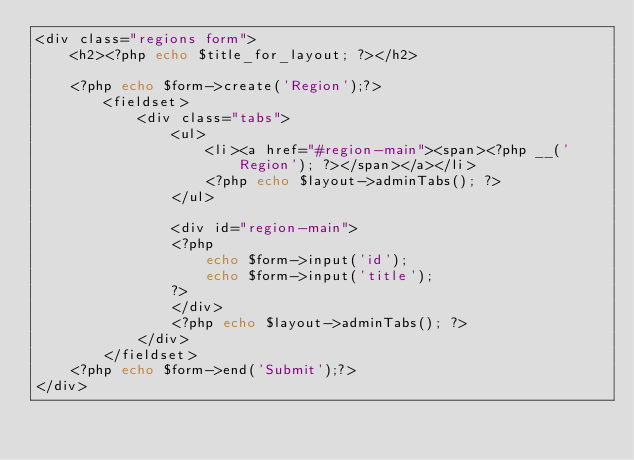Convert code to text. <code><loc_0><loc_0><loc_500><loc_500><_PHP_><div class="regions form">
    <h2><?php echo $title_for_layout; ?></h2>

    <?php echo $form->create('Region');?>
        <fieldset>
            <div class="tabs">
                <ul>
                    <li><a href="#region-main"><span><?php __('Region'); ?></span></a></li>
                    <?php echo $layout->adminTabs(); ?>
                </ul>

                <div id="region-main">
                <?php
                    echo $form->input('id');
                    echo $form->input('title');
                ?>
                </div>
                <?php echo $layout->adminTabs(); ?>
            </div>
        </fieldset>
    <?php echo $form->end('Submit');?>
</div></code> 